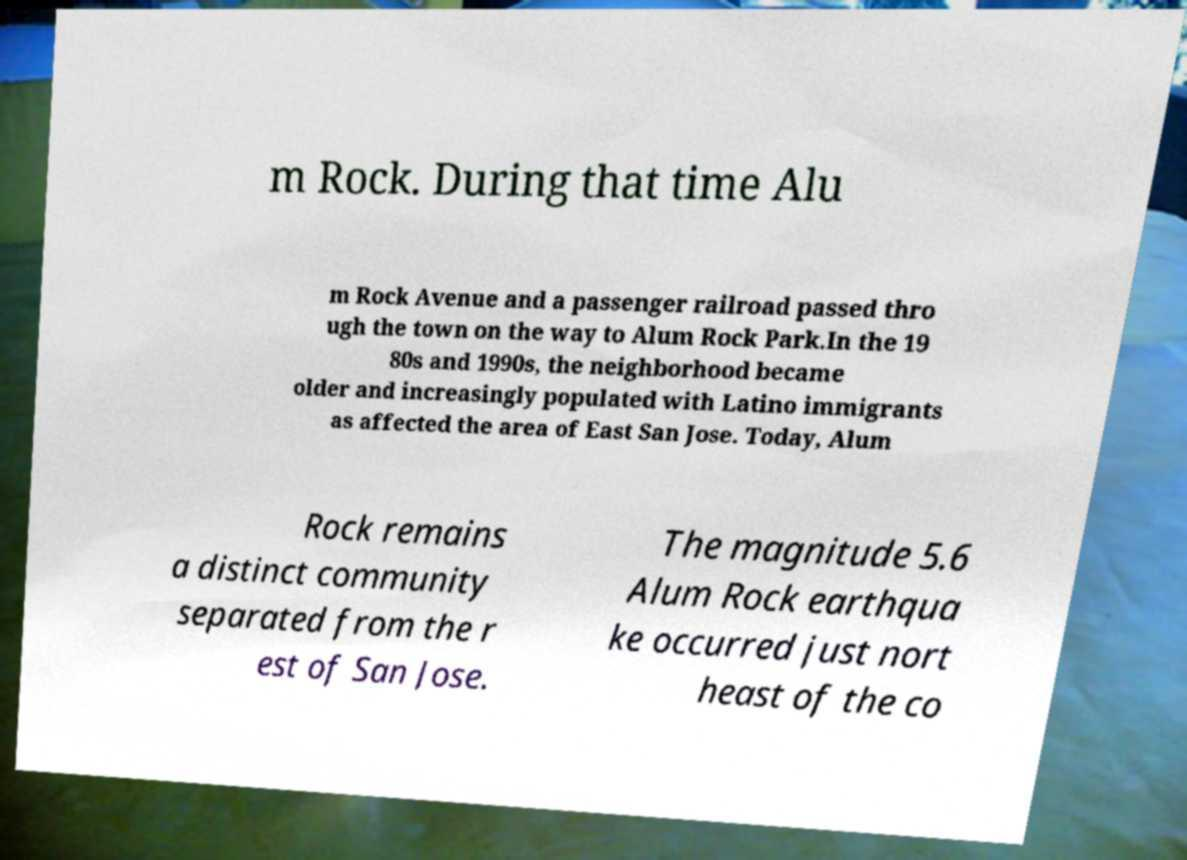Could you assist in decoding the text presented in this image and type it out clearly? m Rock. During that time Alu m Rock Avenue and a passenger railroad passed thro ugh the town on the way to Alum Rock Park.In the 19 80s and 1990s, the neighborhood became older and increasingly populated with Latino immigrants as affected the area of East San Jose. Today, Alum Rock remains a distinct community separated from the r est of San Jose. The magnitude 5.6 Alum Rock earthqua ke occurred just nort heast of the co 